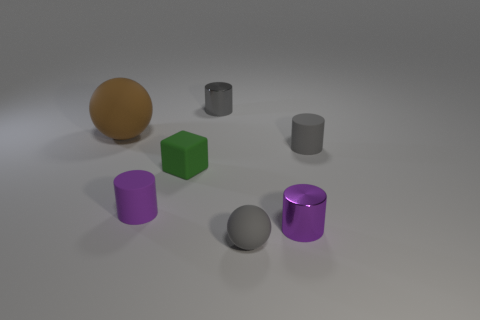Is the purple metal thing the same shape as the large thing?
Ensure brevity in your answer.  No. There is a small matte block; is it the same color as the small metal cylinder that is behind the large brown thing?
Provide a short and direct response. No. What number of things are either tiny things in front of the brown matte object or purple rubber objects that are right of the big rubber ball?
Give a very brief answer. 5. Is the number of green cubes to the left of the tiny gray metallic cylinder greater than the number of small metallic objects in front of the tiny green thing?
Ensure brevity in your answer.  No. There is a purple thing in front of the small rubber cylinder that is to the left of the metallic cylinder that is behind the gray rubber cylinder; what is it made of?
Give a very brief answer. Metal. There is a gray matte object in front of the purple shiny cylinder; does it have the same shape as the shiny thing that is in front of the green rubber block?
Your answer should be very brief. No. Are there any green matte cubes that have the same size as the gray shiny object?
Provide a short and direct response. Yes. What number of blue objects are big things or tiny matte objects?
Make the answer very short. 0. How many small rubber cylinders are the same color as the small block?
Ensure brevity in your answer.  0. Is there anything else that has the same shape as the green object?
Make the answer very short. No. 